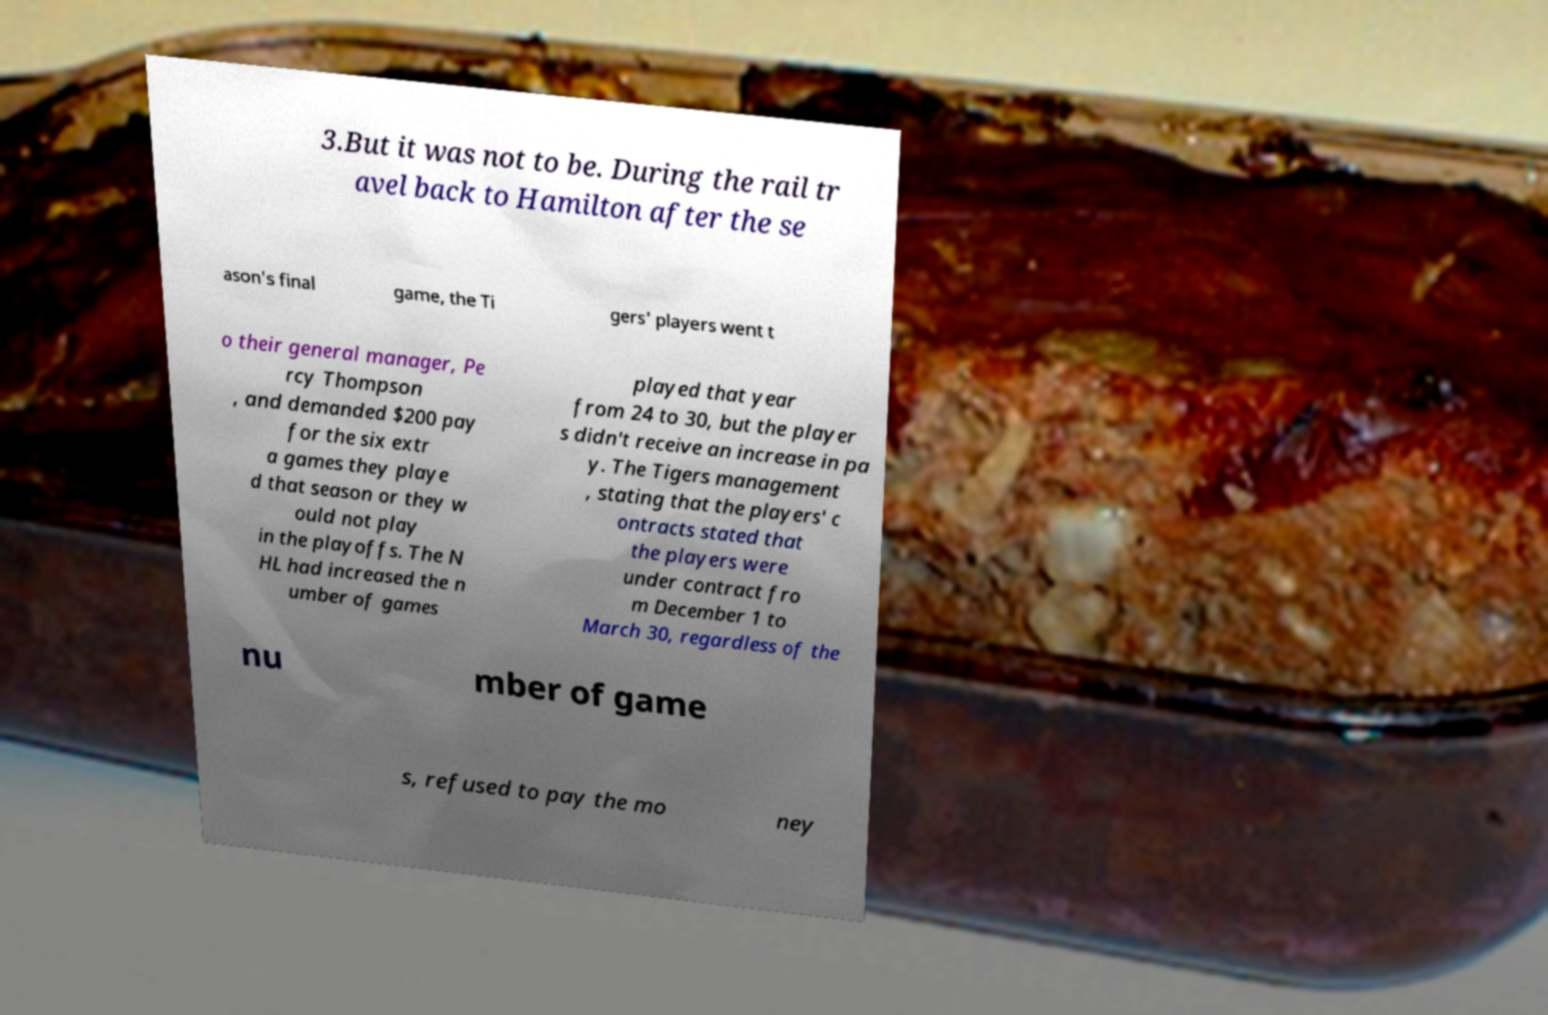Please read and relay the text visible in this image. What does it say? 3.But it was not to be. During the rail tr avel back to Hamilton after the se ason's final game, the Ti gers' players went t o their general manager, Pe rcy Thompson , and demanded $200 pay for the six extr a games they playe d that season or they w ould not play in the playoffs. The N HL had increased the n umber of games played that year from 24 to 30, but the player s didn't receive an increase in pa y. The Tigers management , stating that the players' c ontracts stated that the players were under contract fro m December 1 to March 30, regardless of the nu mber of game s, refused to pay the mo ney 